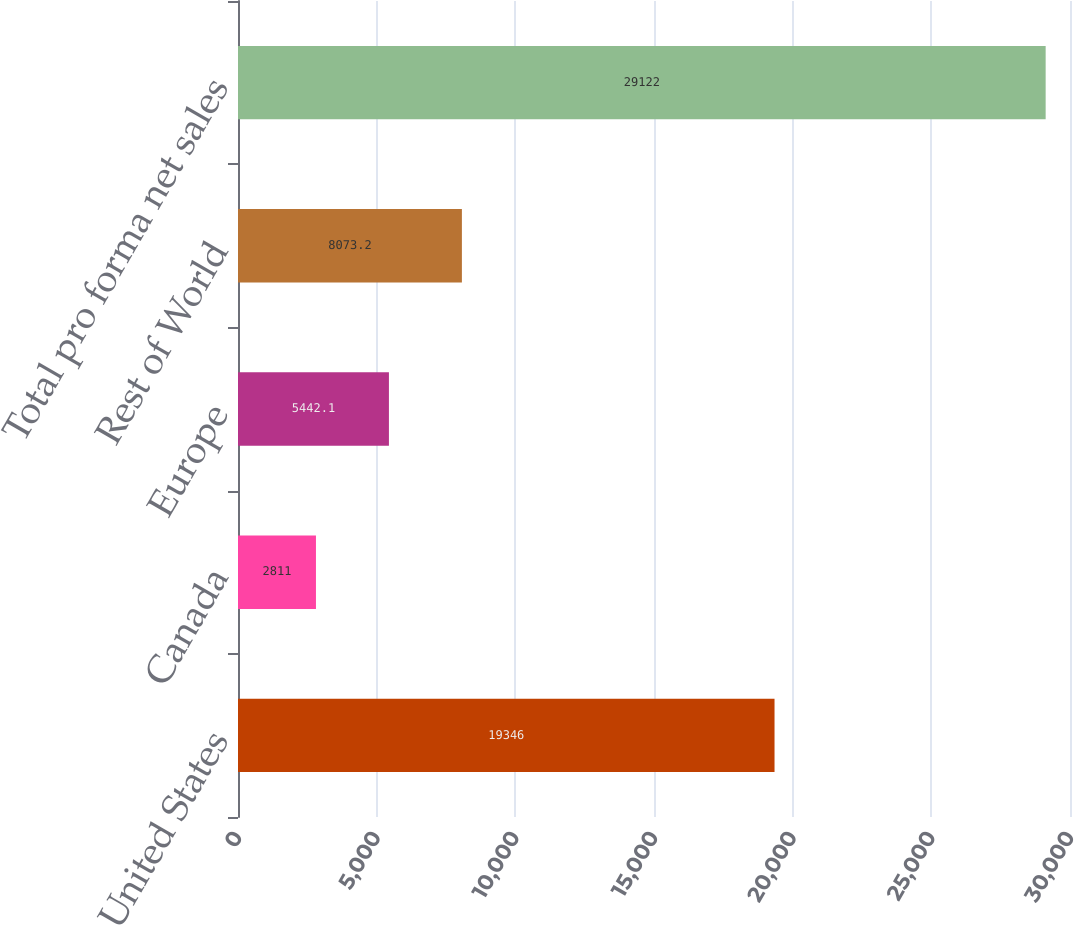<chart> <loc_0><loc_0><loc_500><loc_500><bar_chart><fcel>United States<fcel>Canada<fcel>Europe<fcel>Rest of World<fcel>Total pro forma net sales<nl><fcel>19346<fcel>2811<fcel>5442.1<fcel>8073.2<fcel>29122<nl></chart> 